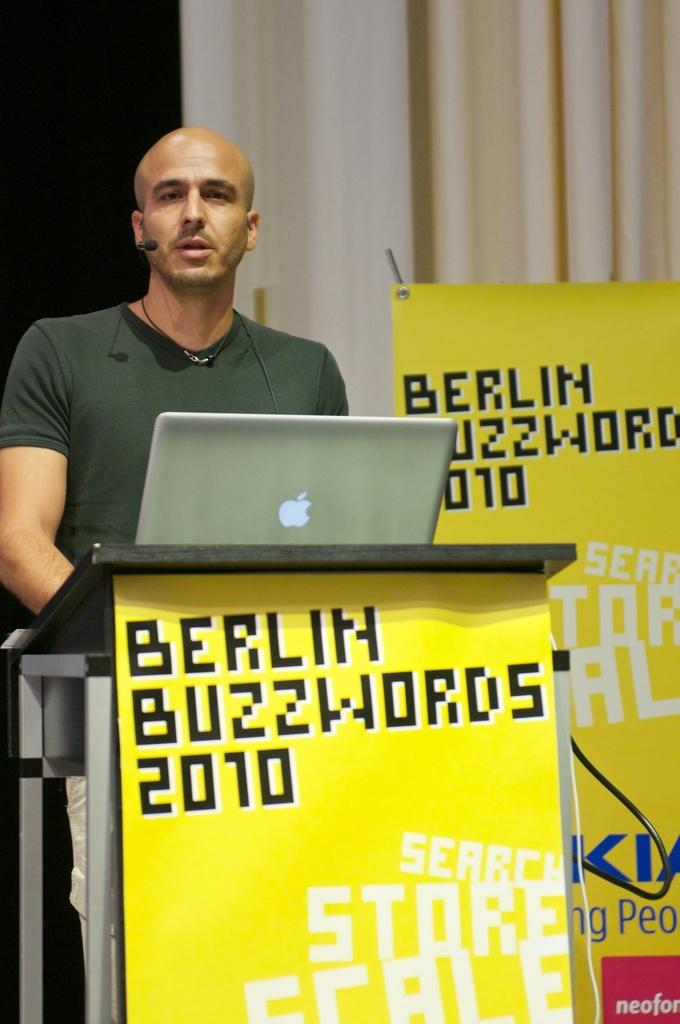What is the person in the image doing? There is a person standing in front of the podium. What object is on the podium? There is a laptop on the podium. What can be seen in the background of the image? There is a yellow banner and a cream curtain visible in the background. What type of coat is the representative wearing in the image? There is no representative present in the image, and no coat is visible. 